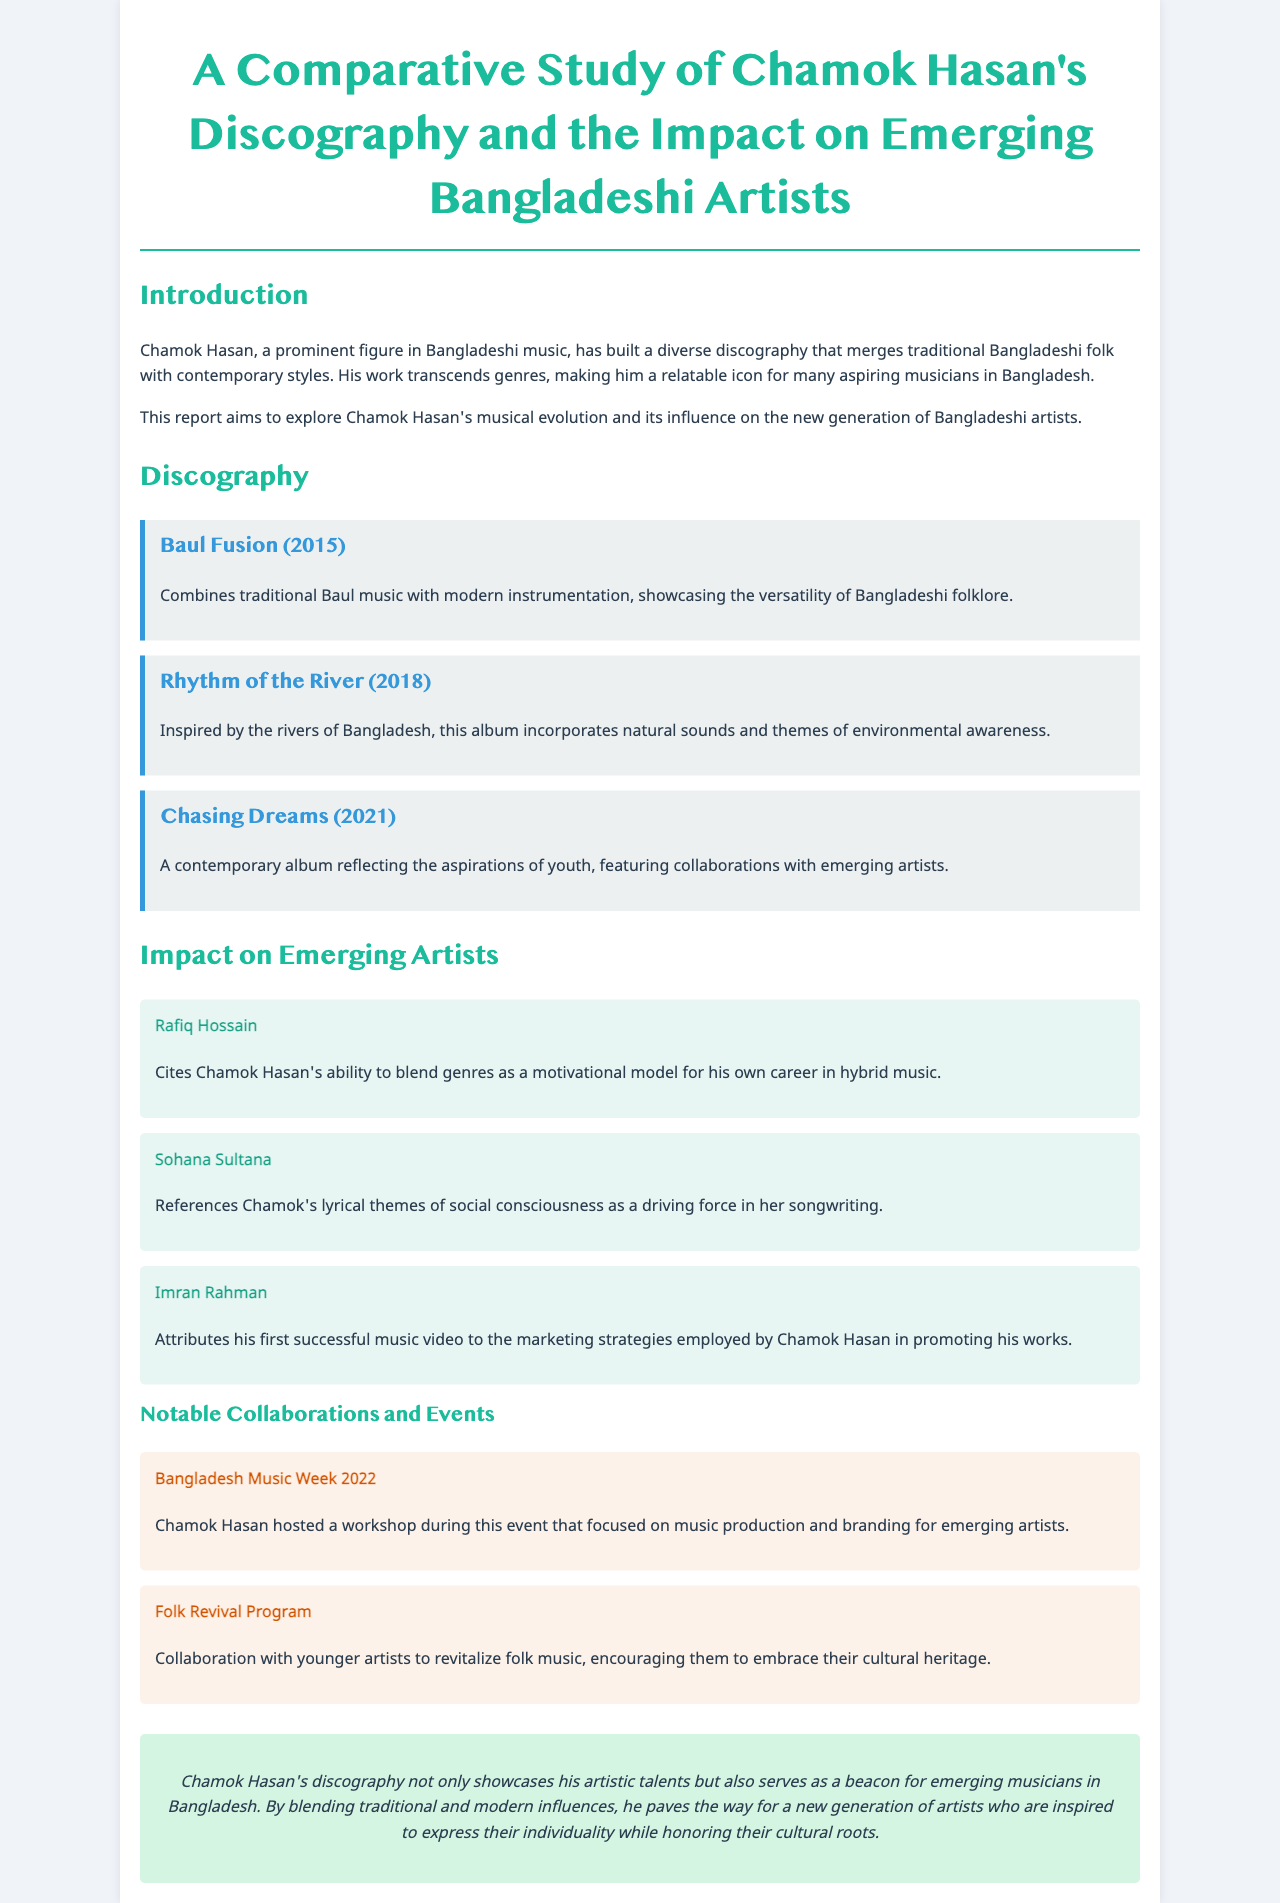what is Chamok Hasan's first album? The first album listed in the document is "Baul Fusion."
Answer: Baul Fusion when was "Rhythm of the River" released? The document states that "Rhythm of the River" was released in 2018.
Answer: 2018 who cites Chamok Hasan's blending of genres as a motivational model? Rafiq Hossain is mentioned as someone who cites Chamok Hasan's blending of genres.
Answer: Rafiq Hossain what event did Chamok Hasan host a workshop during? The document mentions that he hosted a workshop during "Bangladesh Music Week 2022."
Answer: Bangladesh Music Week 2022 what is a key theme in Sohana Sultana's songwriting? The document states that Sohana references Chamok's lyrical themes of social consciousness.
Answer: Social consciousness which album reflects the aspirations of youth? The album "Chasing Dreams" is described as reflecting the aspirations of youth.
Answer: Chasing Dreams how many albums are listed in the discography section? The document lists three albums in the discography section.
Answer: Three what collaboration aims to revitalize folk music? The "Folk Revival Program" is mentioned as a collaboration to revitalize folk music.
Answer: Folk Revival Program 